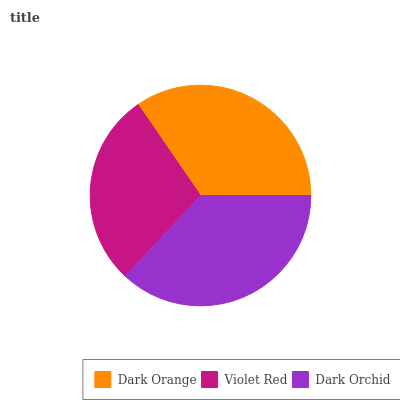Is Violet Red the minimum?
Answer yes or no. Yes. Is Dark Orchid the maximum?
Answer yes or no. Yes. Is Dark Orchid the minimum?
Answer yes or no. No. Is Violet Red the maximum?
Answer yes or no. No. Is Dark Orchid greater than Violet Red?
Answer yes or no. Yes. Is Violet Red less than Dark Orchid?
Answer yes or no. Yes. Is Violet Red greater than Dark Orchid?
Answer yes or no. No. Is Dark Orchid less than Violet Red?
Answer yes or no. No. Is Dark Orange the high median?
Answer yes or no. Yes. Is Dark Orange the low median?
Answer yes or no. Yes. Is Violet Red the high median?
Answer yes or no. No. Is Dark Orchid the low median?
Answer yes or no. No. 